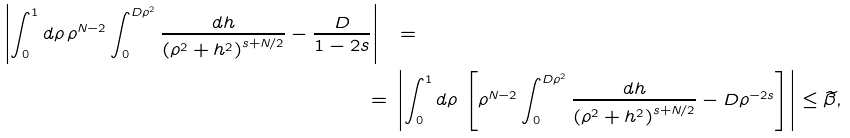Convert formula to latex. <formula><loc_0><loc_0><loc_500><loc_500>\left | \int _ { 0 } ^ { 1 } d \rho \, \rho ^ { N - 2 } \int _ { 0 } ^ { D \rho ^ { 2 } } \frac { d h } { \left ( \rho ^ { 2 } + h ^ { 2 } \right ) ^ { s + N / 2 } } - \frac { D } { 1 - 2 s } \right | \ & = \\ = \ & \left | \int _ { 0 } ^ { 1 } d \rho \, \left [ \rho ^ { N - 2 } \int _ { 0 } ^ { D \rho ^ { 2 } } \frac { d h } { \left ( \rho ^ { 2 } + h ^ { 2 } \right ) ^ { s + N / 2 } } - D \rho ^ { - 2 s } \right ] \right | \leq \widetilde { \beta } ,</formula> 